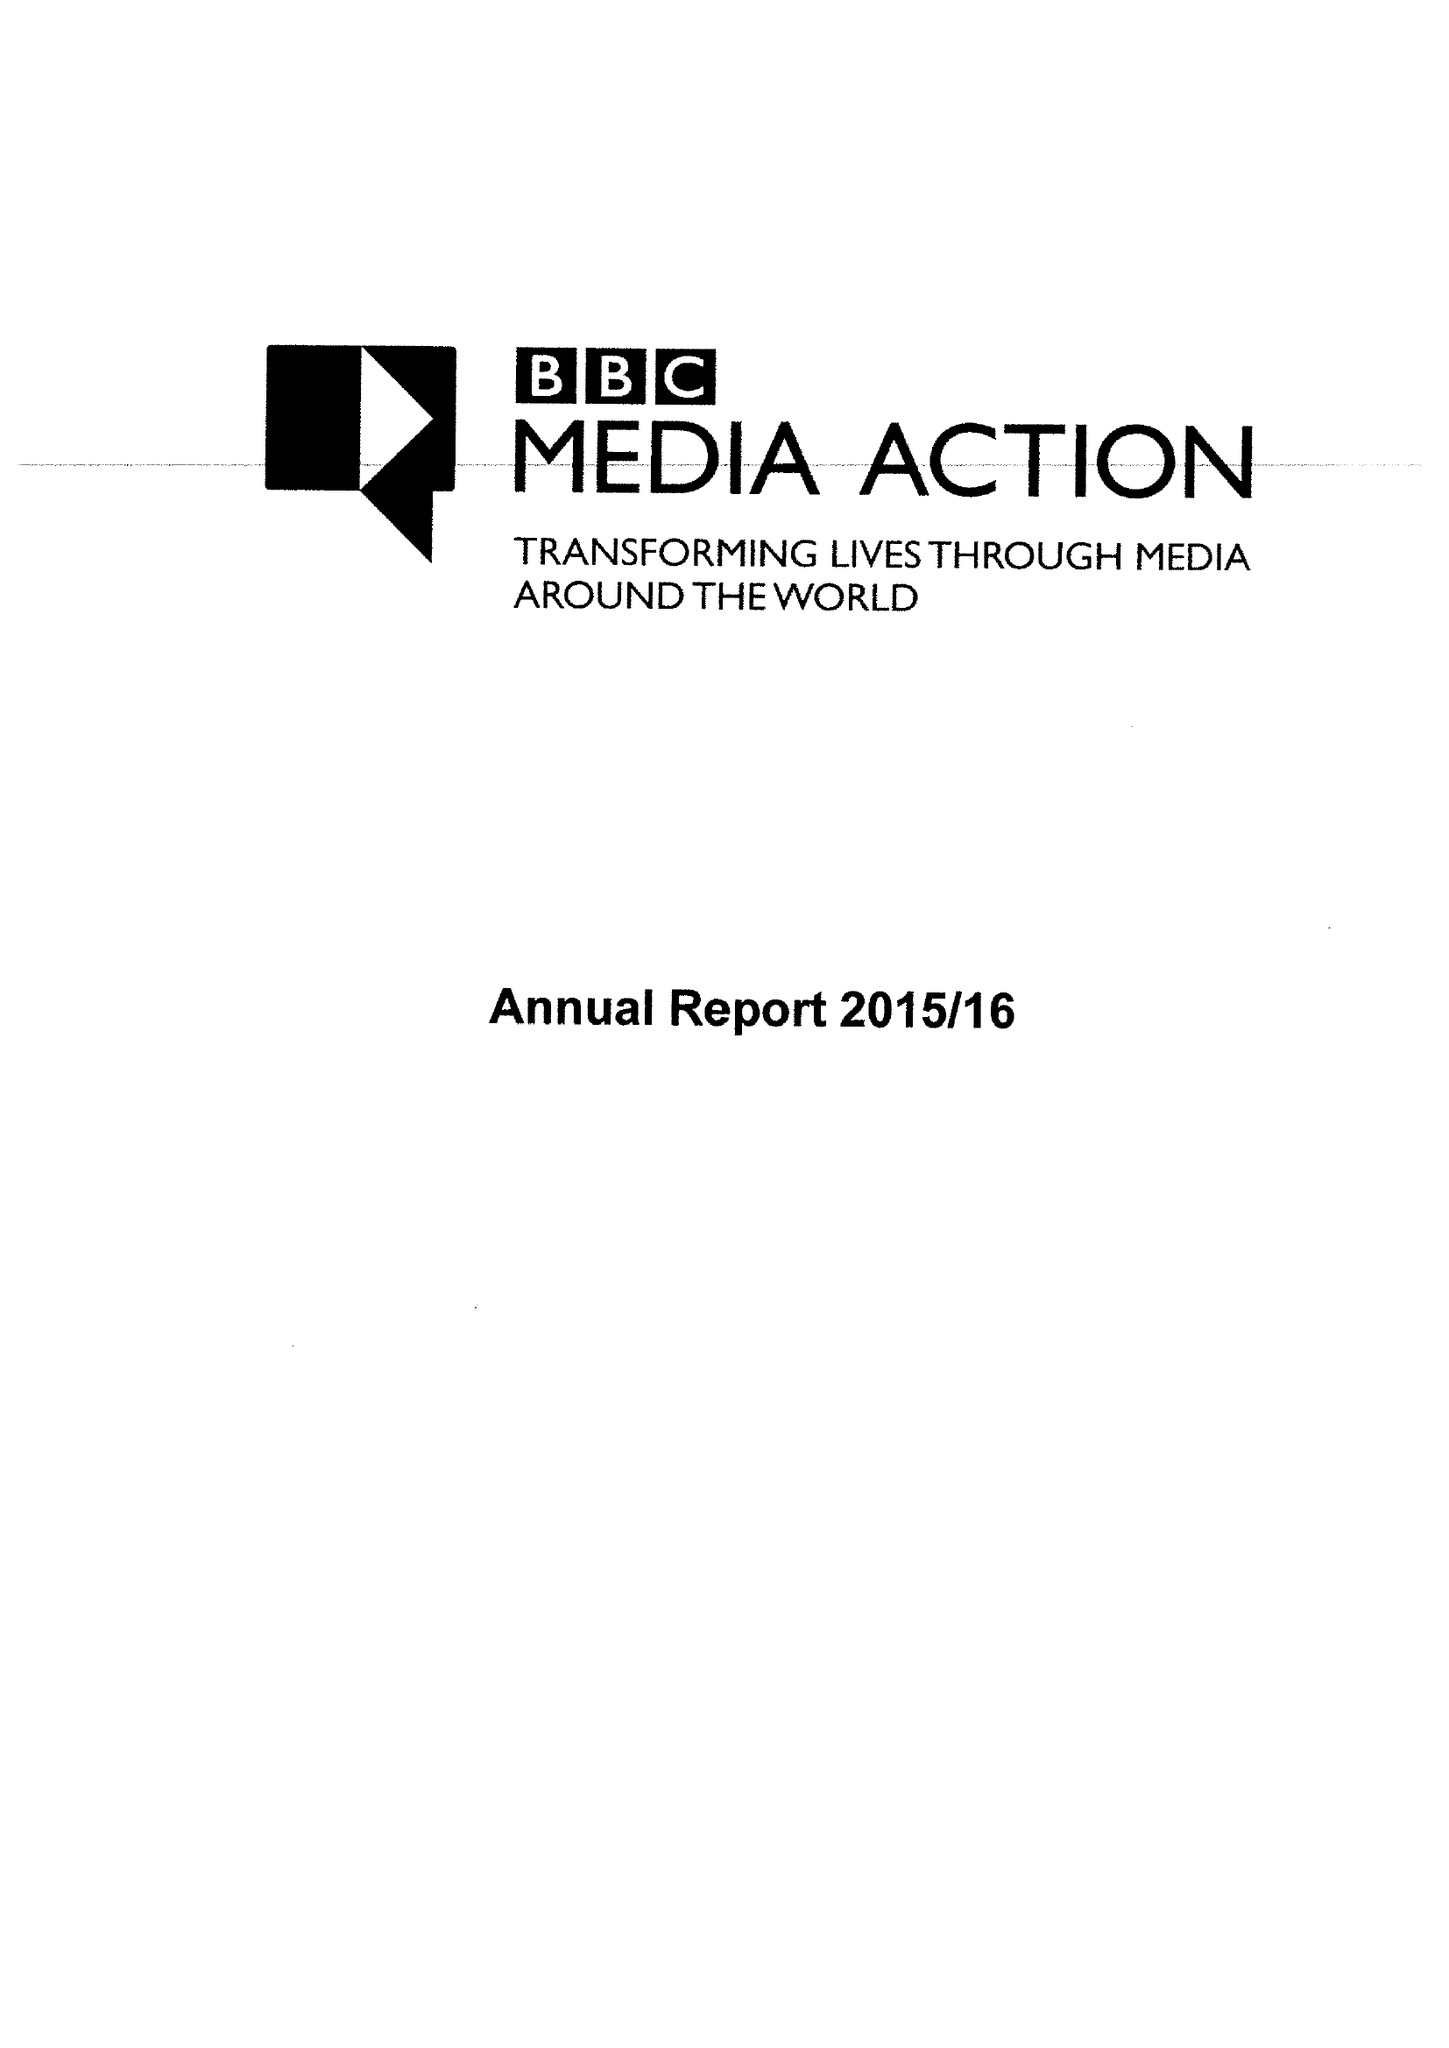What is the value for the address__street_line?
Answer the question using a single word or phrase. PORTLAND PLACE 